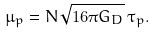Convert formula to latex. <formula><loc_0><loc_0><loc_500><loc_500>\mu _ { p } = N \sqrt { 1 6 \pi G _ { D } } \, \tau _ { p } .</formula> 